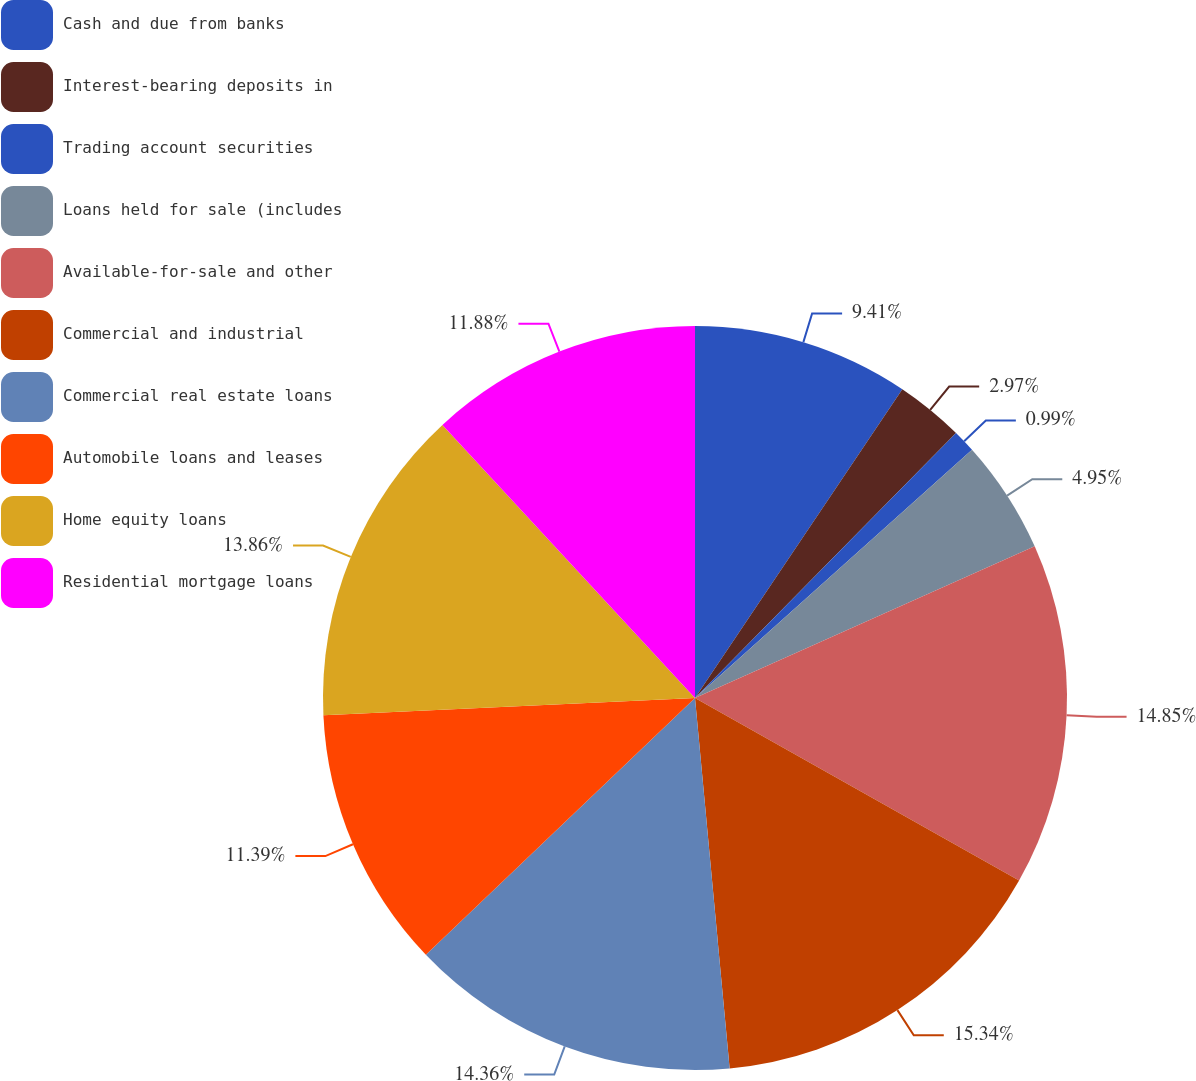Convert chart to OTSL. <chart><loc_0><loc_0><loc_500><loc_500><pie_chart><fcel>Cash and due from banks<fcel>Interest-bearing deposits in<fcel>Trading account securities<fcel>Loans held for sale (includes<fcel>Available-for-sale and other<fcel>Commercial and industrial<fcel>Commercial real estate loans<fcel>Automobile loans and leases<fcel>Home equity loans<fcel>Residential mortgage loans<nl><fcel>9.41%<fcel>2.97%<fcel>0.99%<fcel>4.95%<fcel>14.85%<fcel>15.35%<fcel>14.36%<fcel>11.39%<fcel>13.86%<fcel>11.88%<nl></chart> 